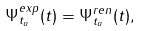<formula> <loc_0><loc_0><loc_500><loc_500>\Psi ^ { e x p } _ { t _ { a } } ( t ) = \Psi ^ { r e n } _ { t _ { a } } ( t ) ,</formula> 